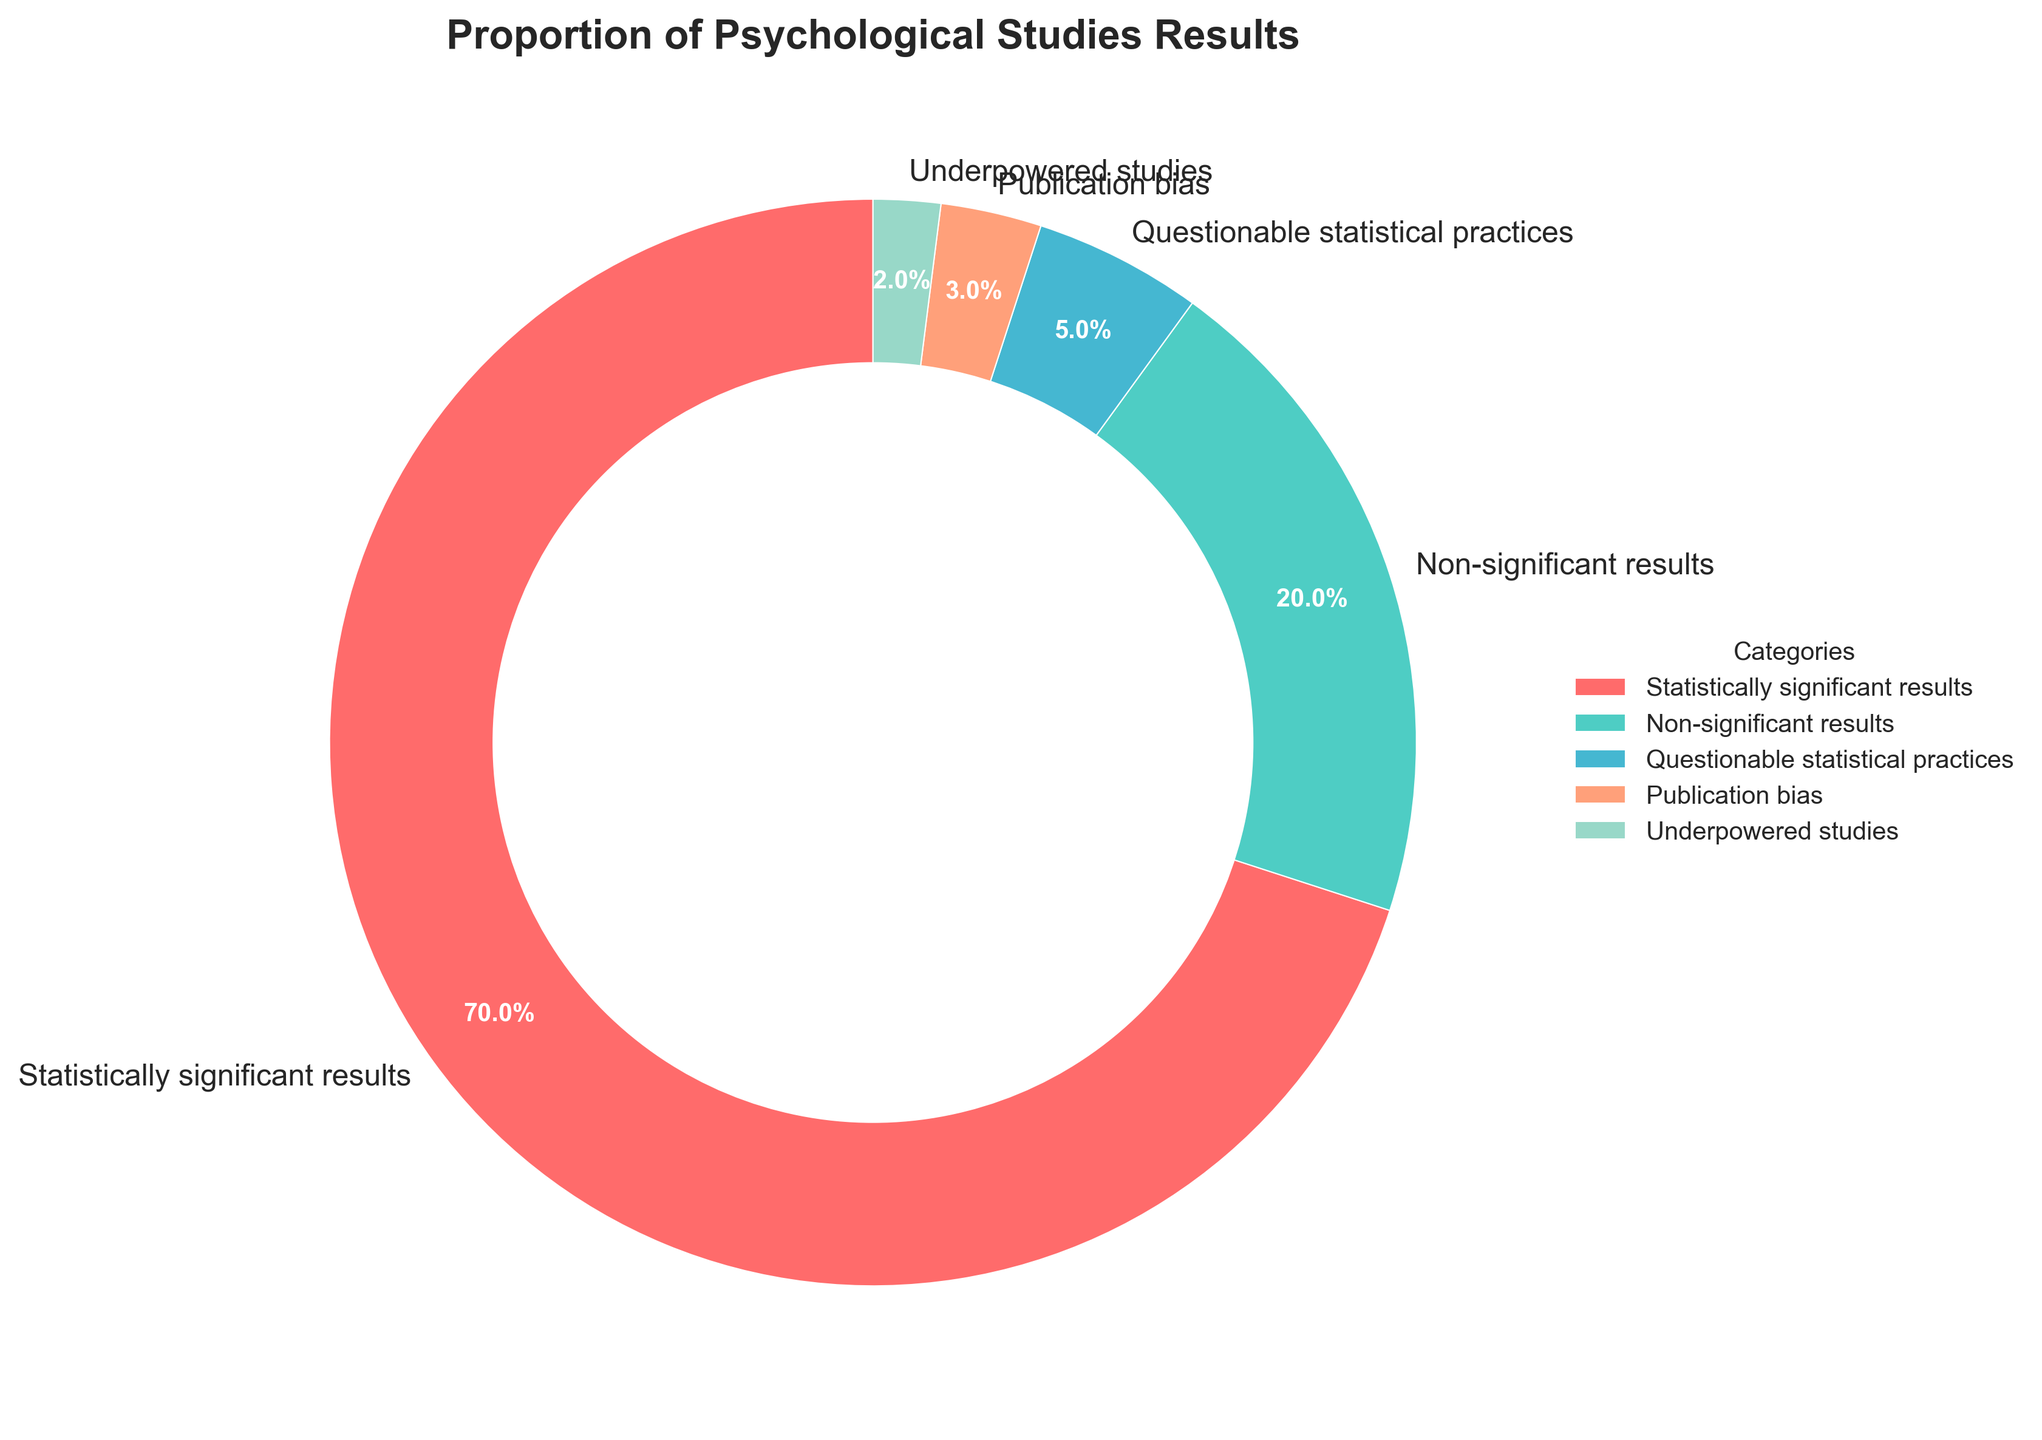What is the proportion of psychological studies with statistically significant results? The proportion of psychological studies with statistically significant results is represented by the largest section of the pie chart, labelled as "Statistically significant results". The percentage for this section is 70%.
Answer: 70% How do the proportions of studies with non-significant results compare to those with questionable statistical practices? The pie chart shows that the percentage of studies with non-significant results is 20%, and those with questionable statistical practices is 5%. Comparing these, 20% is larger than 5%.
Answer: 20% > 5% What's the combined proportion of studies impacted by questionable statistical practices and publication bias? The pie chart indicates that the percentage of studies with questionable statistical practices is 5% and with publication bias is 3%. Combined, these proportions sum up to 5% + 3% = 8%.
Answer: 8% How does the proportion of underpowered studies compare visually with other categories? The segment for underpowered studies is the smallest in the pie chart and is visually distinguishable by its size compared to larger segments such as those for statistically significant and non-significant results.
Answer: Smaller than all other categories What color represents the section with statistically significant results on the pie chart? The section with statistically significant results is represented by the color red. This can be identified by matching the label with the color segment in the pie chart.
Answer: Red What is the difference in percentage points between studies with statistically significant and non-significant results? From the pie chart, the statistically significant results category is 70% and the non-significant results category is 20%. The difference between them is 70% - 20% = 50%.
Answer: 50% Which category has the smallest proportion in the pie chart? By observing the pie chart, the category with the smallest proportion is labelled "Underpowered studies", which has a percentage of 2%.
Answer: Underpowered studies Are there more studies with non-significant results than the sum of studies with publication bias and underpowered studies combined? The pie chart shows 20% for non-significant results, and summing publication bias (3%) and underpowered studies (2%) gives 5%. Therefore, 20% (non-significant) is greater than 5% (publication bias + underpowered studies).
Answer: Yes What percentage of studies fall under "Questionable statistical practices"? The pie chart indicates that the percentage of studies falling under "Questionable statistical practices" is 5%.
Answer: 5% If you combine non-significant results and questionable statistical practices, what proportion of studies do they represent? From the pie chart, non-significant results account for 20% and questionable statistical practices account for 5%. Combined, these represent 20% + 5% = 25% of the studies.
Answer: 25% 